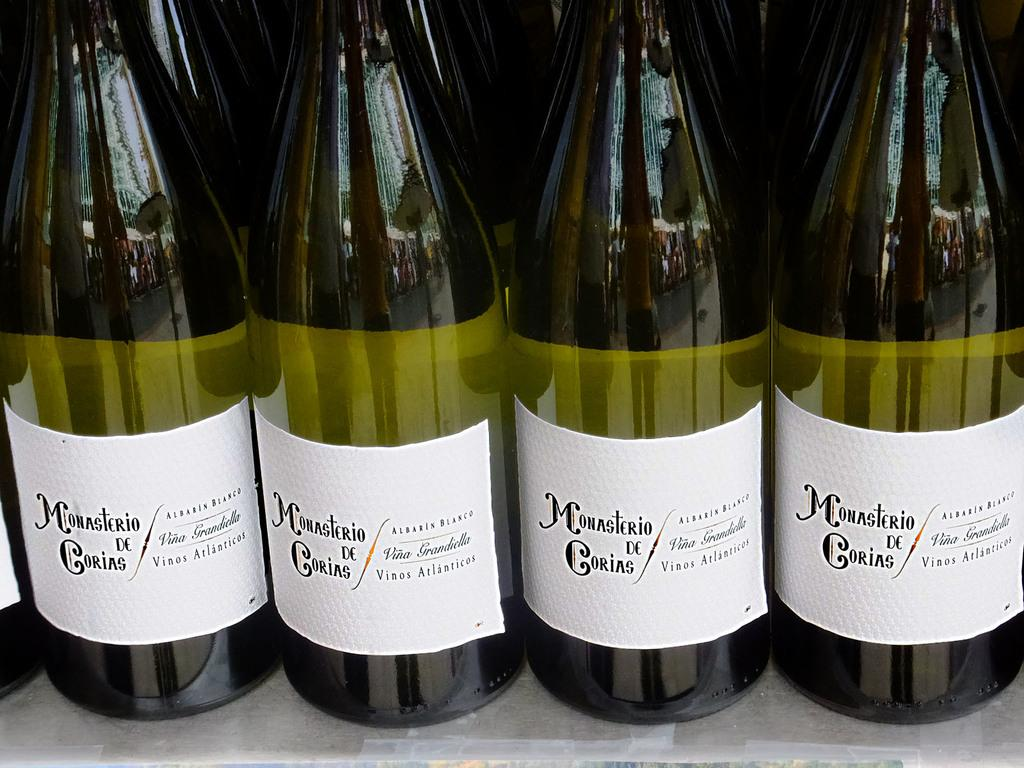<image>
Present a compact description of the photo's key features. Four bottles of Monasterio de Corias wine sit on a shelf. 